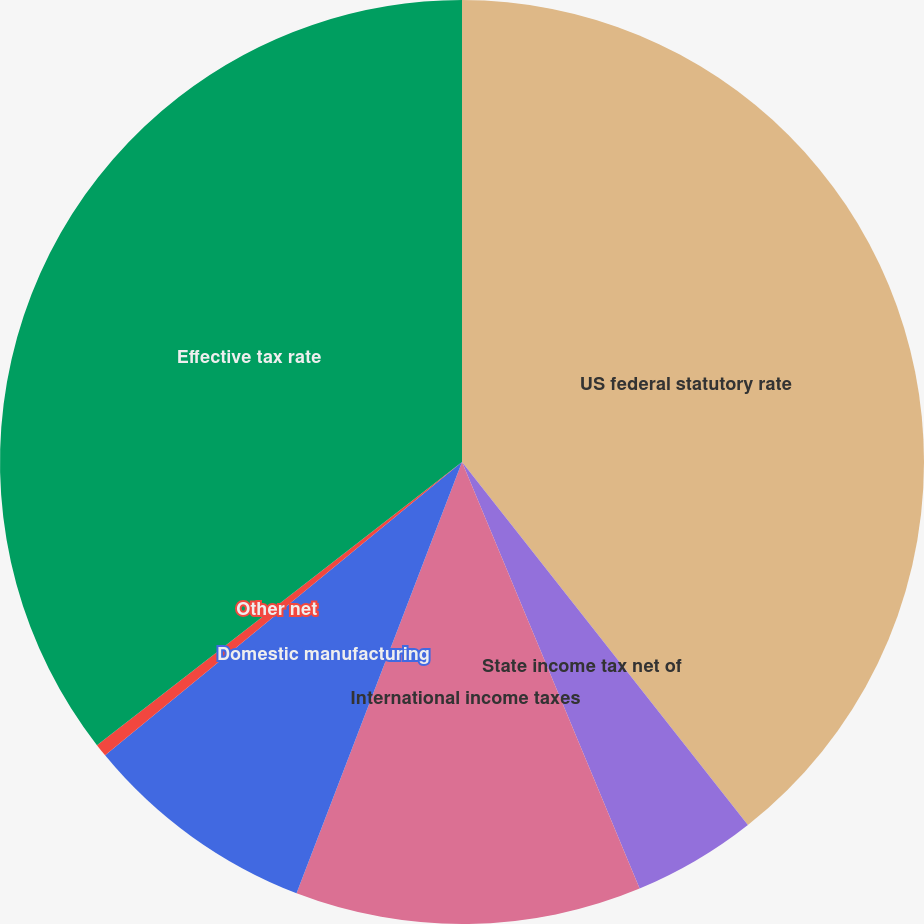Convert chart to OTSL. <chart><loc_0><loc_0><loc_500><loc_500><pie_chart><fcel>US federal statutory rate<fcel>State income tax net of<fcel>International income taxes<fcel>Domestic manufacturing<fcel>Other net<fcel>Effective tax rate<nl><fcel>39.38%<fcel>4.34%<fcel>12.11%<fcel>8.22%<fcel>0.45%<fcel>35.5%<nl></chart> 